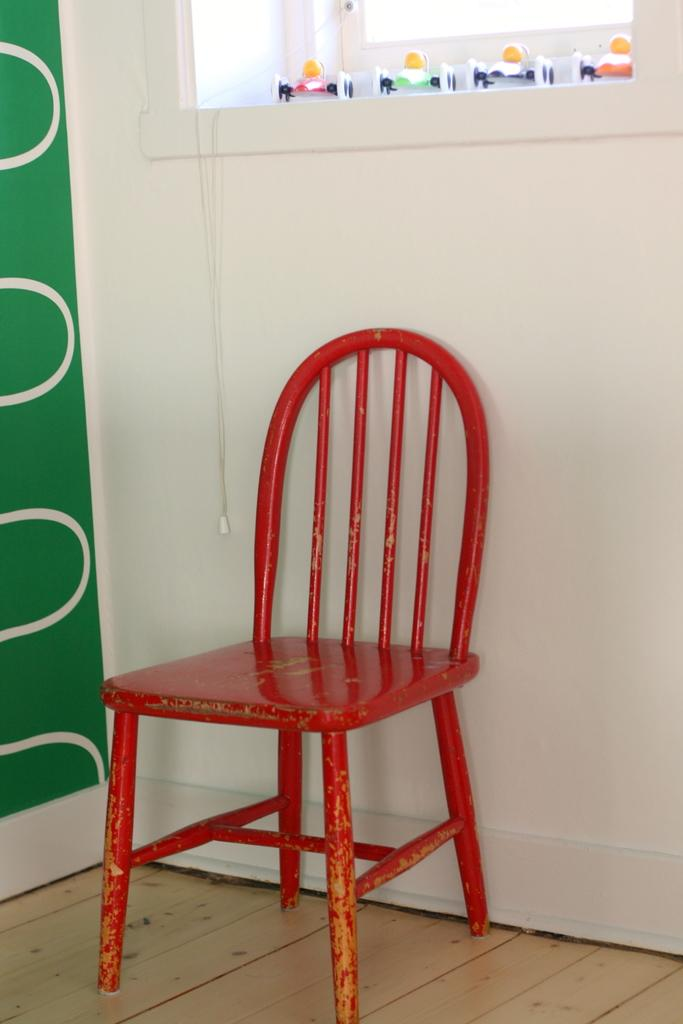What type of furniture is present in the image? There is a chair in the image. What can be seen on the left side of the image? There is a wall on the left side of the image. What architectural feature is visible at the top of the image? There is: There is a window visible at the top of the image. What type of sheet is draped over the chair in the image? There is no sheet present in the image; only a chair, a wall, and a window are visible. 